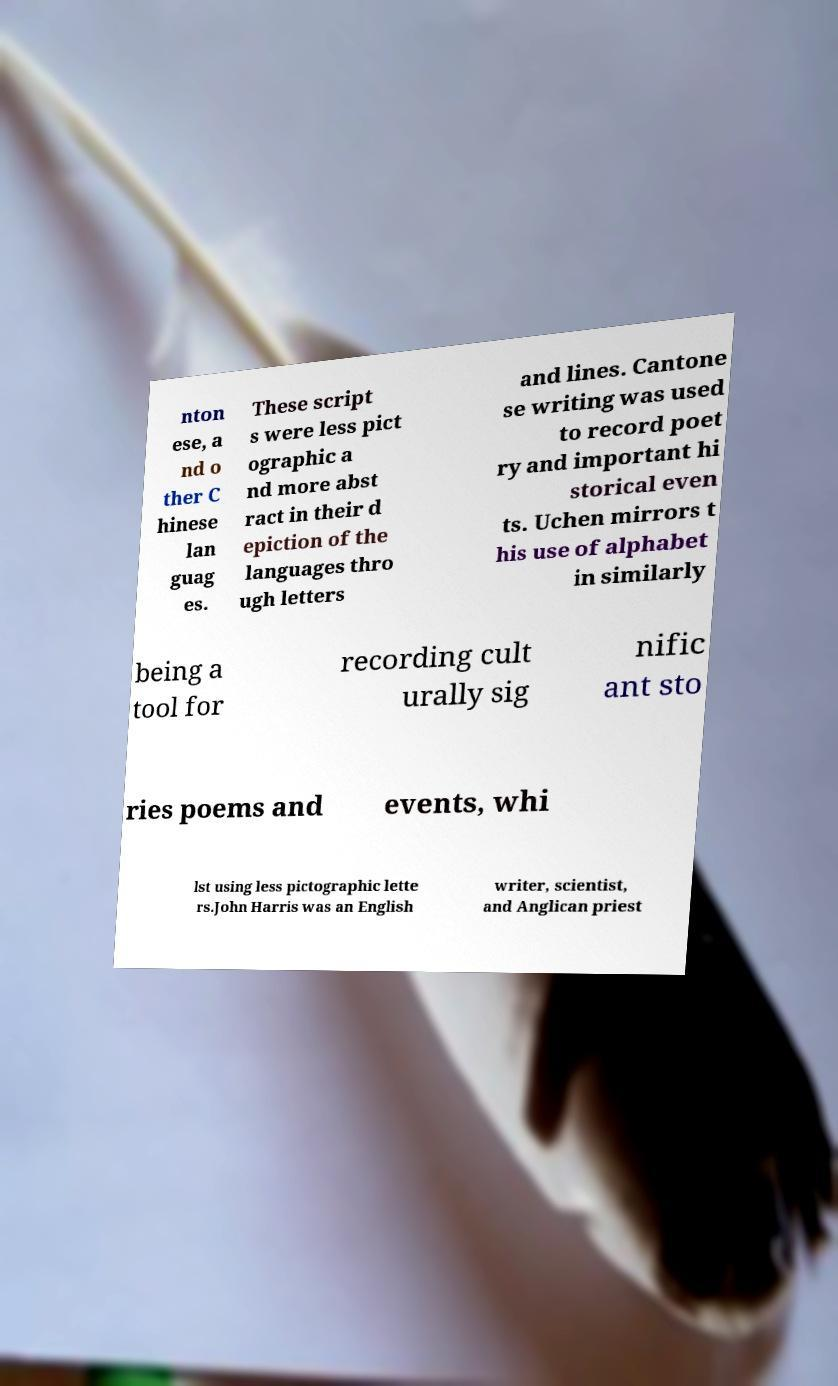What messages or text are displayed in this image? I need them in a readable, typed format. nton ese, a nd o ther C hinese lan guag es. These script s were less pict ographic a nd more abst ract in their d epiction of the languages thro ugh letters and lines. Cantone se writing was used to record poet ry and important hi storical even ts. Uchen mirrors t his use of alphabet in similarly being a tool for recording cult urally sig nific ant sto ries poems and events, whi lst using less pictographic lette rs.John Harris was an English writer, scientist, and Anglican priest 